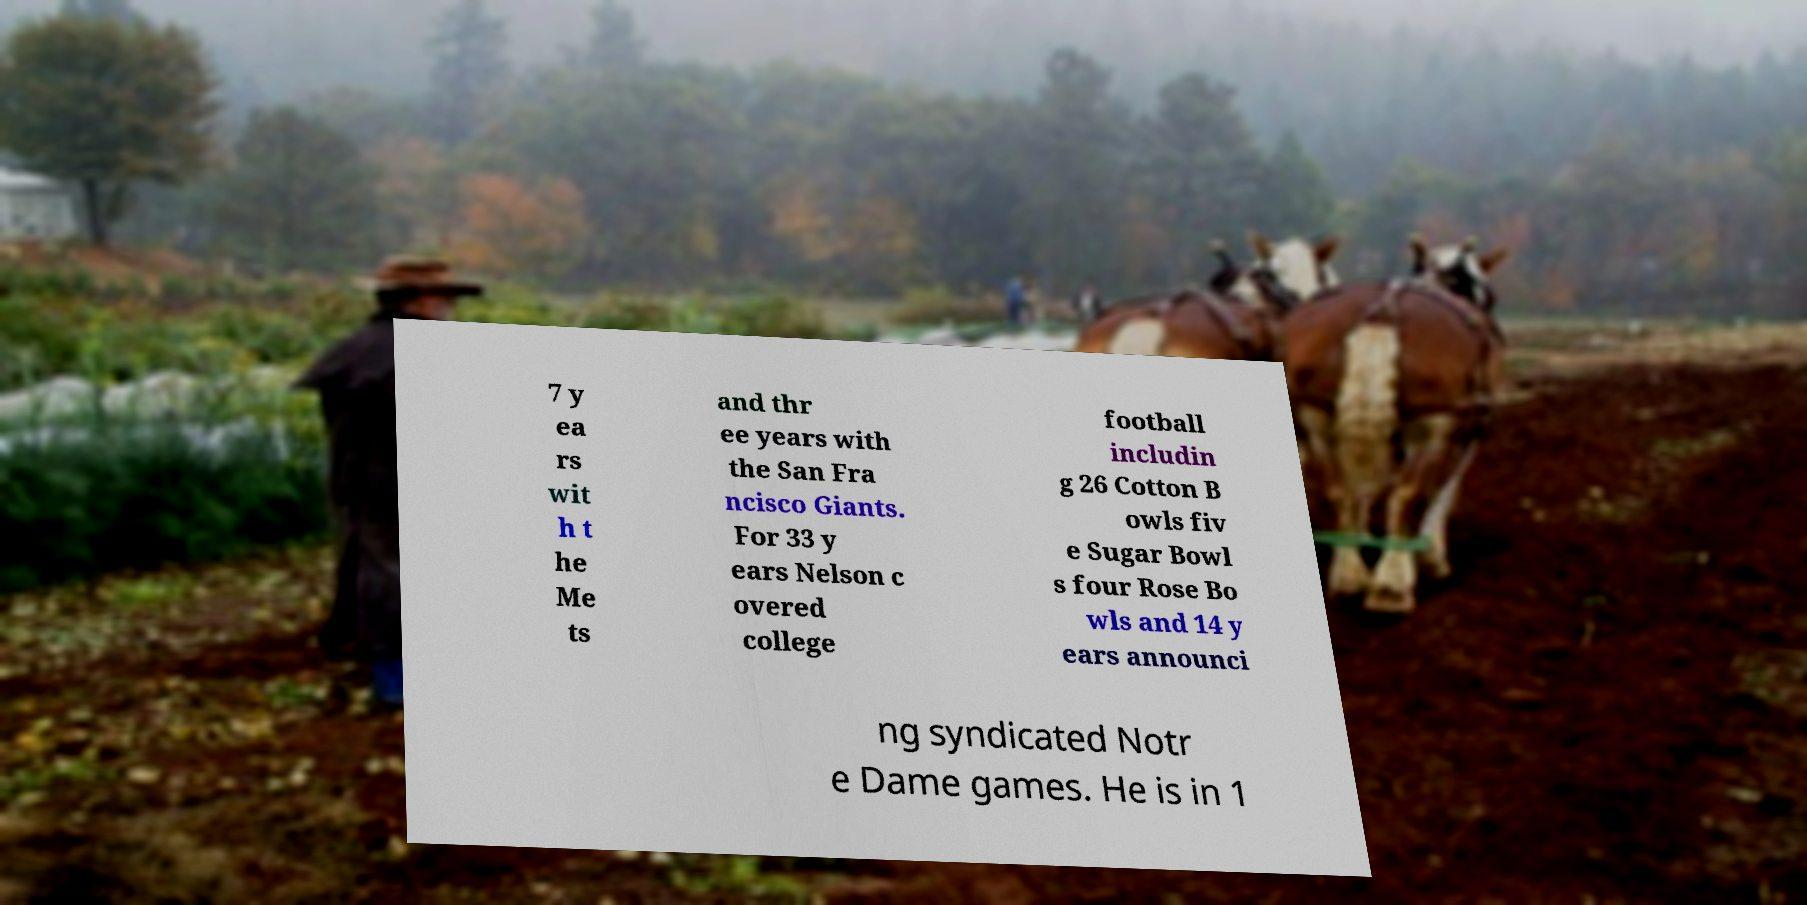Can you accurately transcribe the text from the provided image for me? 7 y ea rs wit h t he Me ts and thr ee years with the San Fra ncisco Giants. For 33 y ears Nelson c overed college football includin g 26 Cotton B owls fiv e Sugar Bowl s four Rose Bo wls and 14 y ears announci ng syndicated Notr e Dame games. He is in 1 